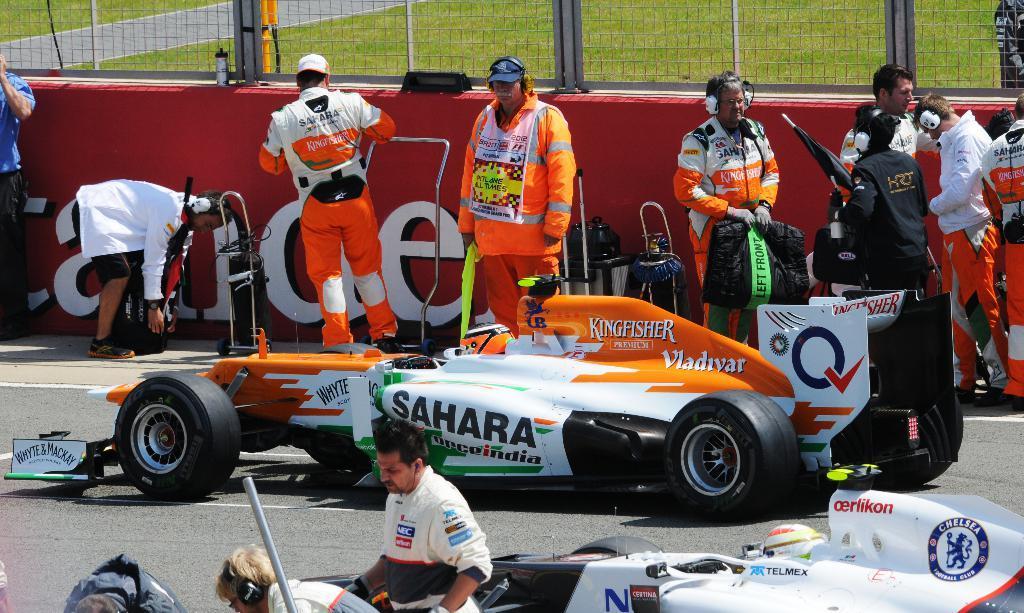Could you give a brief overview of what you see in this image? In this image I can see group of people standing, the person in front wearing orange color dress, background I can see a red color board attached to the wall, in front I can see a vehicle in white and orange color, and I can see the grass in green color. 